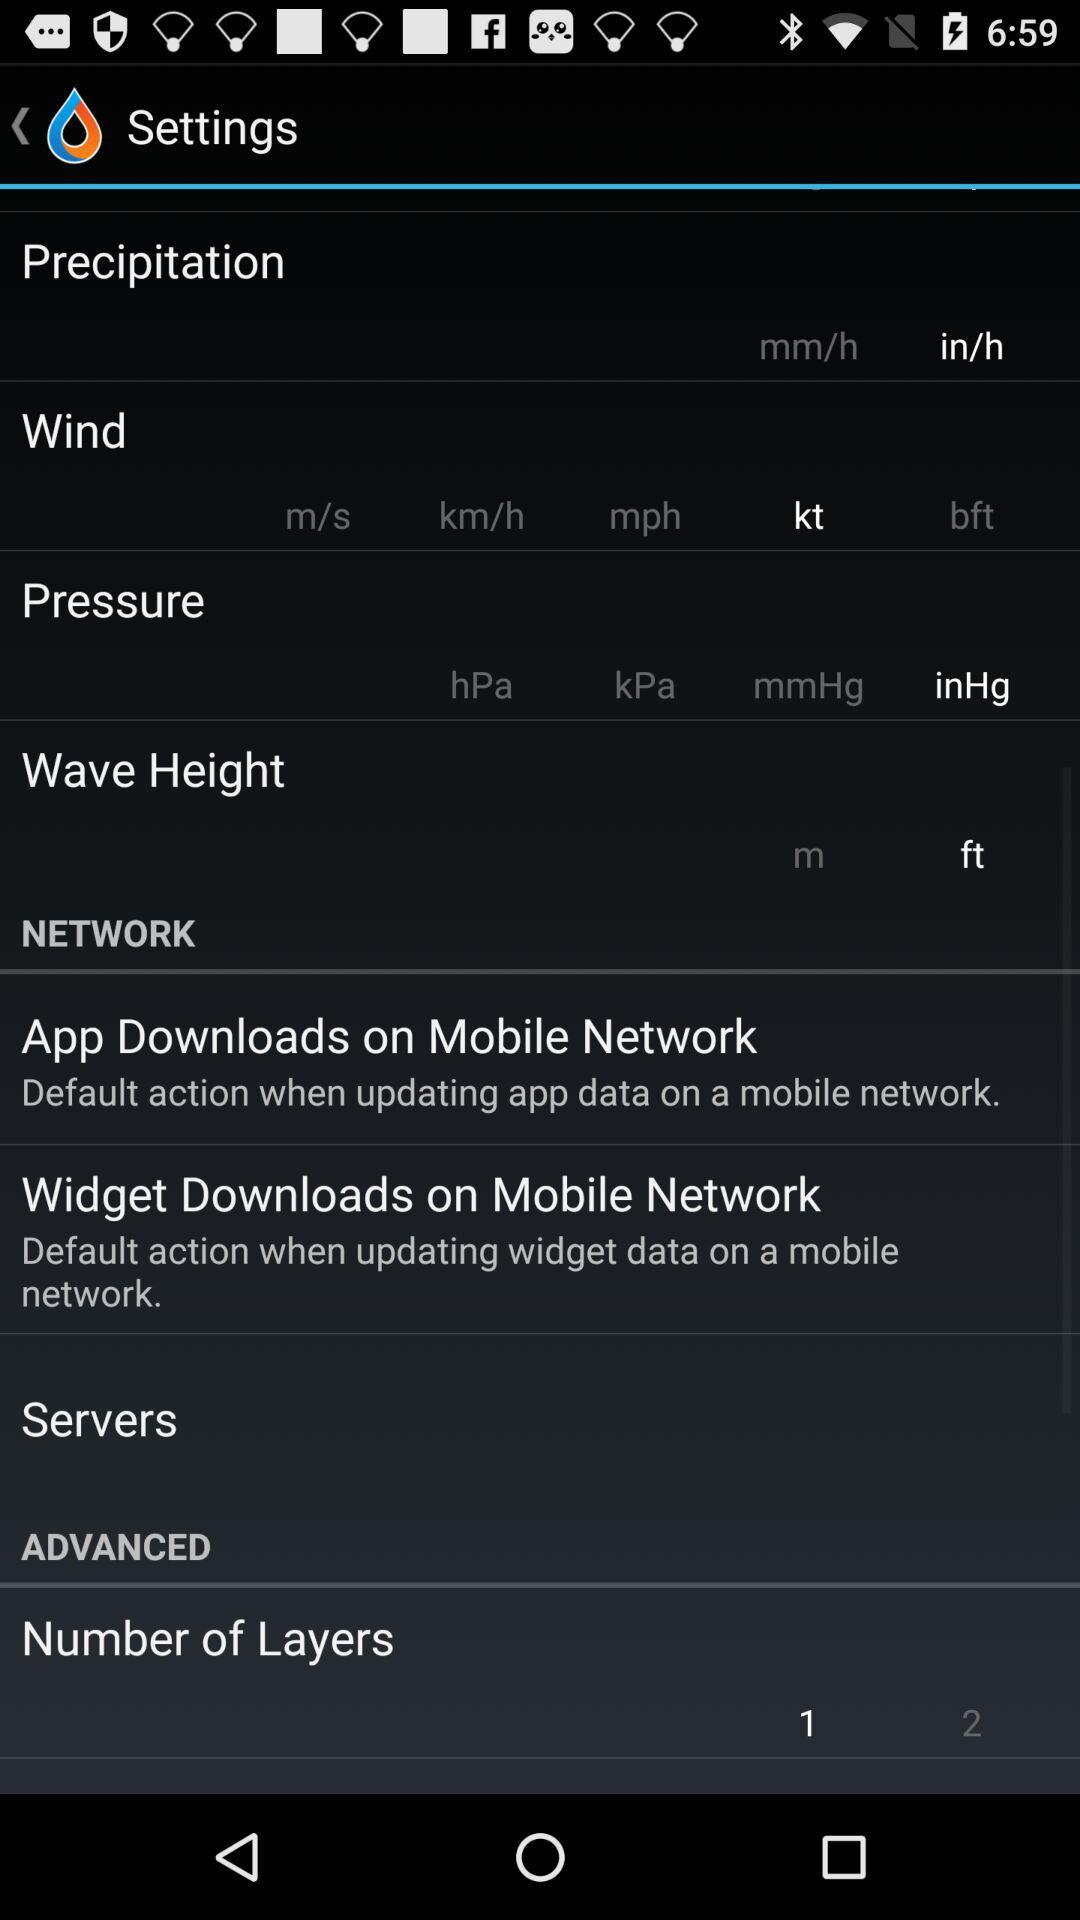What is the wind unit? The wind unit is kt. 